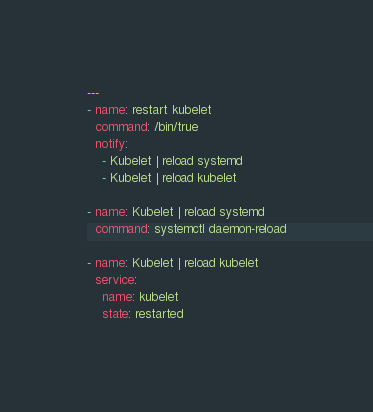<code> <loc_0><loc_0><loc_500><loc_500><_YAML_>---
- name: restart kubelet
  command: /bin/true
  notify:
    - Kubelet | reload systemd
    - Kubelet | reload kubelet

- name: Kubelet | reload systemd
  command: systemctl daemon-reload

- name: Kubelet | reload kubelet
  service:
    name: kubelet
    state: restarted</code> 